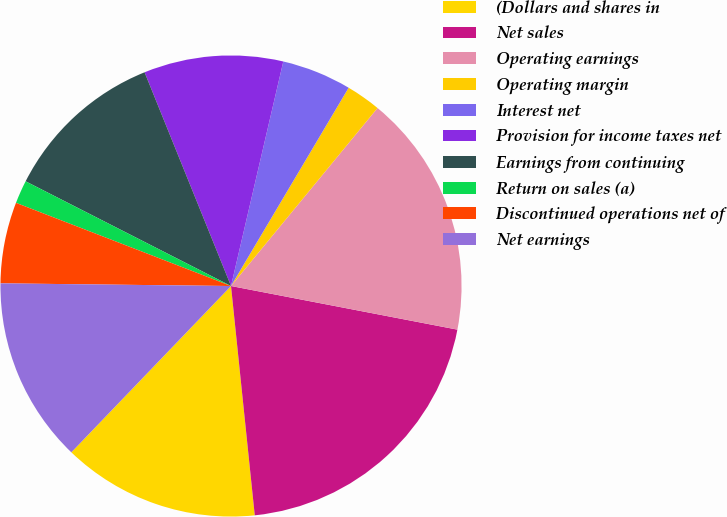Convert chart. <chart><loc_0><loc_0><loc_500><loc_500><pie_chart><fcel>(Dollars and shares in<fcel>Net sales<fcel>Operating earnings<fcel>Operating margin<fcel>Interest net<fcel>Provision for income taxes net<fcel>Earnings from continuing<fcel>Return on sales (a)<fcel>Discontinued operations net of<fcel>Net earnings<nl><fcel>13.82%<fcel>20.33%<fcel>17.07%<fcel>2.44%<fcel>4.88%<fcel>9.76%<fcel>11.38%<fcel>1.63%<fcel>5.69%<fcel>13.01%<nl></chart> 